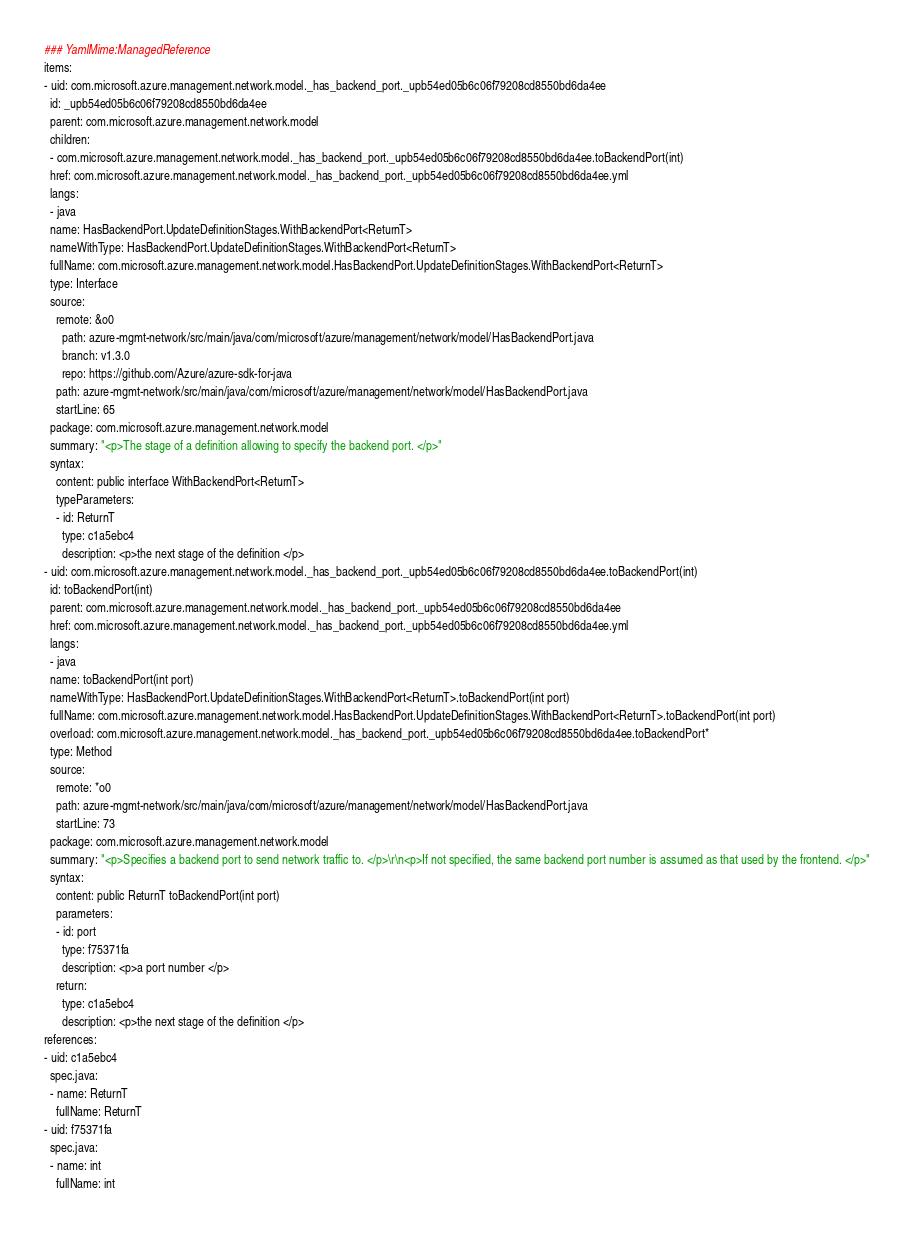Convert code to text. <code><loc_0><loc_0><loc_500><loc_500><_YAML_>### YamlMime:ManagedReference
items:
- uid: com.microsoft.azure.management.network.model._has_backend_port._upb54ed05b6c06f79208cd8550bd6da4ee
  id: _upb54ed05b6c06f79208cd8550bd6da4ee
  parent: com.microsoft.azure.management.network.model
  children:
  - com.microsoft.azure.management.network.model._has_backend_port._upb54ed05b6c06f79208cd8550bd6da4ee.toBackendPort(int)
  href: com.microsoft.azure.management.network.model._has_backend_port._upb54ed05b6c06f79208cd8550bd6da4ee.yml
  langs:
  - java
  name: HasBackendPort.UpdateDefinitionStages.WithBackendPort<ReturnT>
  nameWithType: HasBackendPort.UpdateDefinitionStages.WithBackendPort<ReturnT>
  fullName: com.microsoft.azure.management.network.model.HasBackendPort.UpdateDefinitionStages.WithBackendPort<ReturnT>
  type: Interface
  source:
    remote: &o0
      path: azure-mgmt-network/src/main/java/com/microsoft/azure/management/network/model/HasBackendPort.java
      branch: v1.3.0
      repo: https://github.com/Azure/azure-sdk-for-java
    path: azure-mgmt-network/src/main/java/com/microsoft/azure/management/network/model/HasBackendPort.java
    startLine: 65
  package: com.microsoft.azure.management.network.model
  summary: "<p>The stage of a definition allowing to specify the backend port. </p>"
  syntax:
    content: public interface WithBackendPort<ReturnT>
    typeParameters:
    - id: ReturnT
      type: c1a5ebc4
      description: <p>the next stage of the definition </p>
- uid: com.microsoft.azure.management.network.model._has_backend_port._upb54ed05b6c06f79208cd8550bd6da4ee.toBackendPort(int)
  id: toBackendPort(int)
  parent: com.microsoft.azure.management.network.model._has_backend_port._upb54ed05b6c06f79208cd8550bd6da4ee
  href: com.microsoft.azure.management.network.model._has_backend_port._upb54ed05b6c06f79208cd8550bd6da4ee.yml
  langs:
  - java
  name: toBackendPort(int port)
  nameWithType: HasBackendPort.UpdateDefinitionStages.WithBackendPort<ReturnT>.toBackendPort(int port)
  fullName: com.microsoft.azure.management.network.model.HasBackendPort.UpdateDefinitionStages.WithBackendPort<ReturnT>.toBackendPort(int port)
  overload: com.microsoft.azure.management.network.model._has_backend_port._upb54ed05b6c06f79208cd8550bd6da4ee.toBackendPort*
  type: Method
  source:
    remote: *o0
    path: azure-mgmt-network/src/main/java/com/microsoft/azure/management/network/model/HasBackendPort.java
    startLine: 73
  package: com.microsoft.azure.management.network.model
  summary: "<p>Specifies a backend port to send network traffic to. </p>\r\n<p>If not specified, the same backend port number is assumed as that used by the frontend. </p>"
  syntax:
    content: public ReturnT toBackendPort(int port)
    parameters:
    - id: port
      type: f75371fa
      description: <p>a port number </p>
    return:
      type: c1a5ebc4
      description: <p>the next stage of the definition </p>
references:
- uid: c1a5ebc4
  spec.java:
  - name: ReturnT
    fullName: ReturnT
- uid: f75371fa
  spec.java:
  - name: int
    fullName: int</code> 